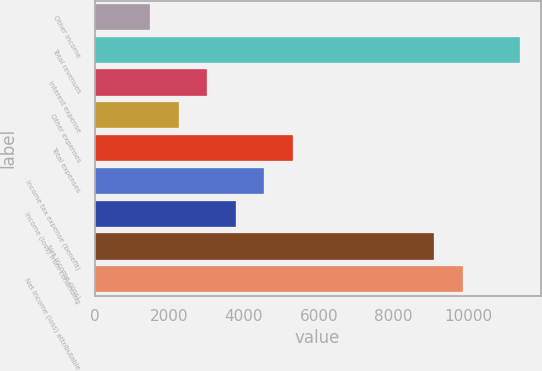Convert chart to OTSL. <chart><loc_0><loc_0><loc_500><loc_500><bar_chart><fcel>Other income<fcel>Total revenues<fcel>Interest expense<fcel>Other expenses<fcel>Total expenses<fcel>Income tax expense (benefit)<fcel>Income (loss) from continuing<fcel>Net income (loss)<fcel>Net income (loss) attributable<nl><fcel>1487<fcel>11376.4<fcel>3014.6<fcel>2250.8<fcel>5306<fcel>4542.2<fcel>3778.4<fcel>9085<fcel>9848.8<nl></chart> 